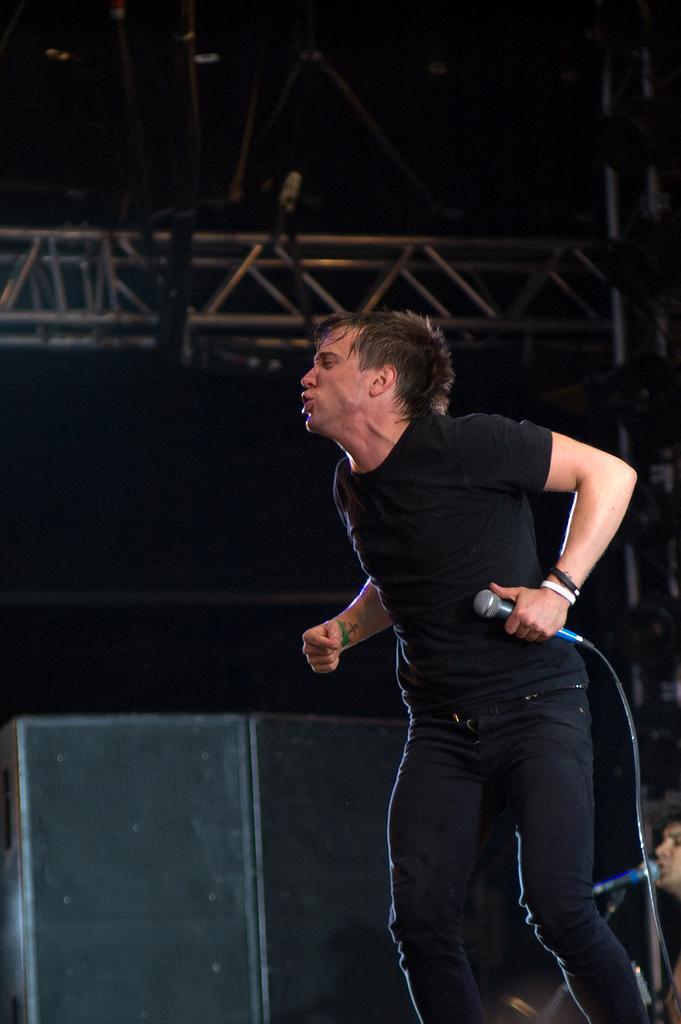In one or two sentences, can you explain what this image depicts? In this picture we can see few people, in the middle of the given image we can see a man, he is holding a microphone in his hand, in the background we can find few speakers and metal rods. 